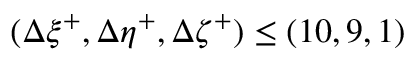<formula> <loc_0><loc_0><loc_500><loc_500>( \Delta \xi ^ { + } , \Delta \eta ^ { + } , \Delta \zeta ^ { + } ) \leq ( 1 0 , 9 , 1 )</formula> 